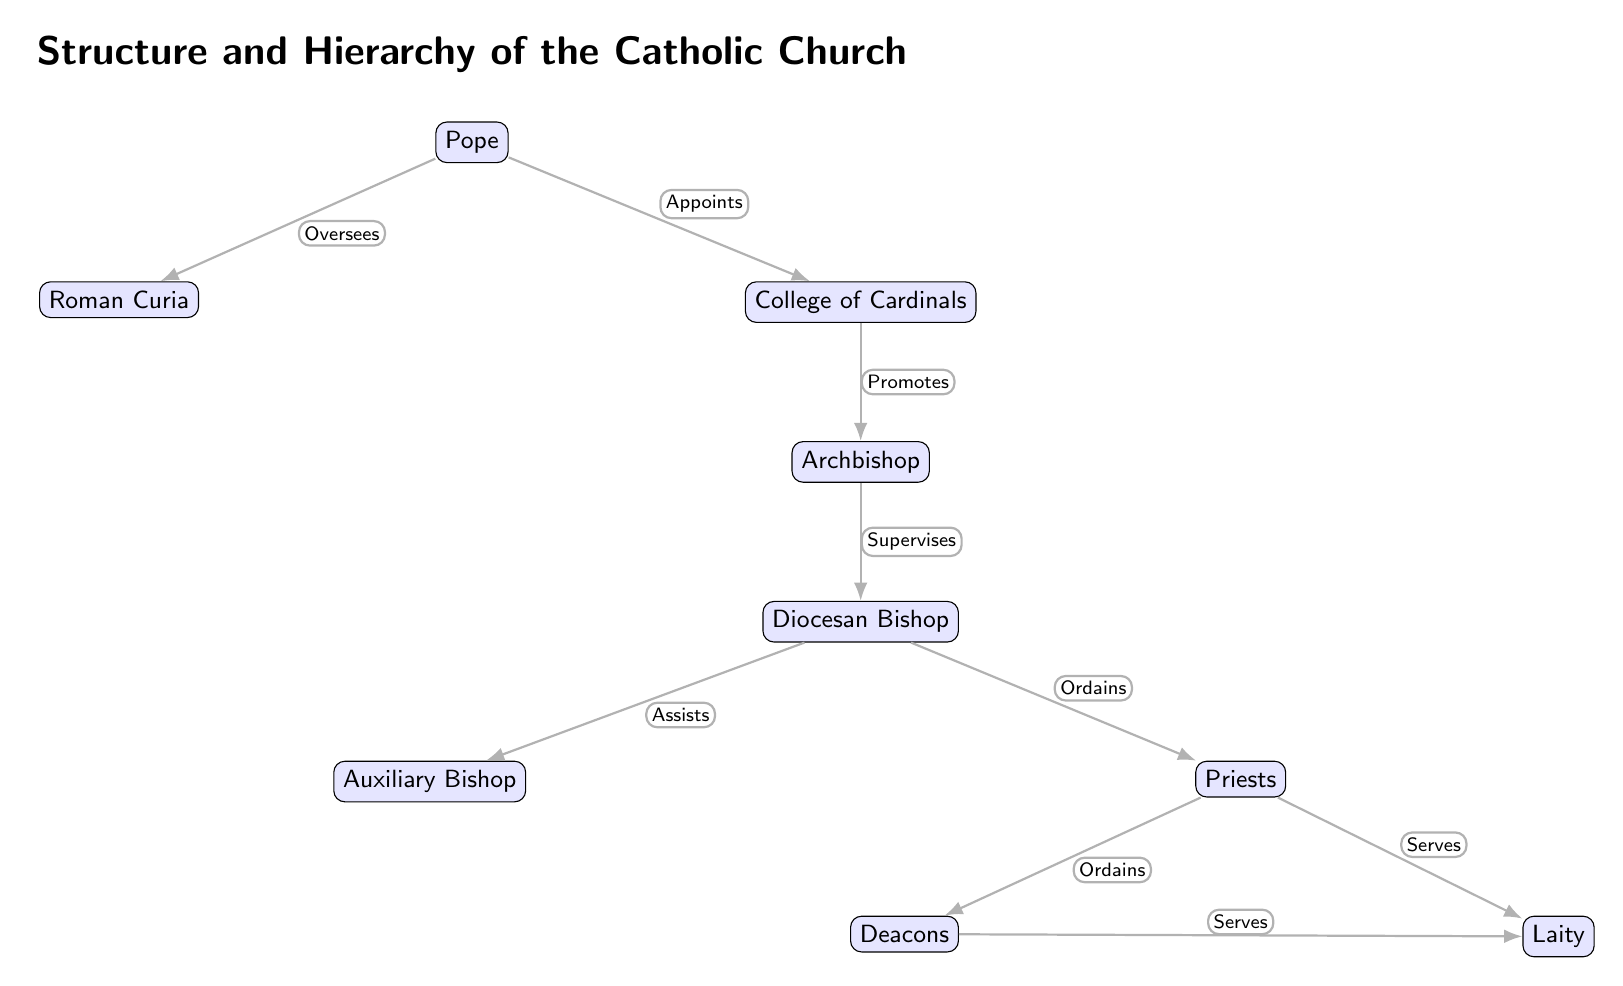What is the highest position in the hierarchy? The highest position in the Catholic Church hierarchy, as shown in the diagram, is the Pope. This is indicated by the placement of the Pope at the top of the structure.
Answer: Pope How many main positions are directly under the Pope? From the diagram, two main positions are shown directly under the Pope: the Roman Curia and the College of Cardinals. This can be counted from the two nodes branching out from the Pope.
Answer: 2 Who does the College of Cardinals promote? The diagram shows that the College of Cardinals promotes the Archbishop. This relationship is clearly indicated by the edge connecting the two nodes with the label "Promotes."
Answer: Archbishop What position supervises the Diocesan Bishop? According to the diagram, the Archbishop supervises the Diocesan Bishop. This is shown through the directional edge pointing from the Archbishop to the Diocesan Bishop, labeled "Supervises."
Answer: Archbishop Which group serves the Laity? The diagram indicates that both Priests and Deacons serve the Laity. This is deduced from the edges leading from both nodes (Priests and Deacons) to the Laity, each marked with the label "Serves."
Answer: Priests, Deacons What is the relationship between the Diocesan Bishop and Auxiliary Bishop? The diagram specifies that the Diocesan Bishop assists the Auxiliary Bishop, as indicated by the connecting edge labeled "Assists."
Answer: Assists Which hierarchy level is directly above the Priests? The hierarchy level directly above the Priests in the diagram is the Diocesan Bishop. This is clear from the position of the Diocesan Bishop above the Priests on the diagram, connected by the label "Ordains."
Answer: Diocesan Bishop How many edges connect to the Laity? There are two edges that connect to the Laity in the diagram: one from Priests and one from Deacons. By counting those edges, it is clear how many groups serve the Laity.
Answer: 2 What is the primary role of the Roman Curia? The primary role of the Roman Curia, indicated by the edge from the Pope, is to be overseen by the Pope. Thus, it serves a supportive and administrative role under the Pope's direction.
Answer: Oversees 